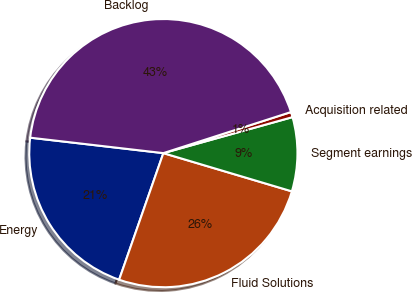<chart> <loc_0><loc_0><loc_500><loc_500><pie_chart><fcel>Energy<fcel>Fluid Solutions<fcel>Segment earnings<fcel>Acquisition related<fcel>Backlog<nl><fcel>21.49%<fcel>25.75%<fcel>8.93%<fcel>0.63%<fcel>43.21%<nl></chart> 